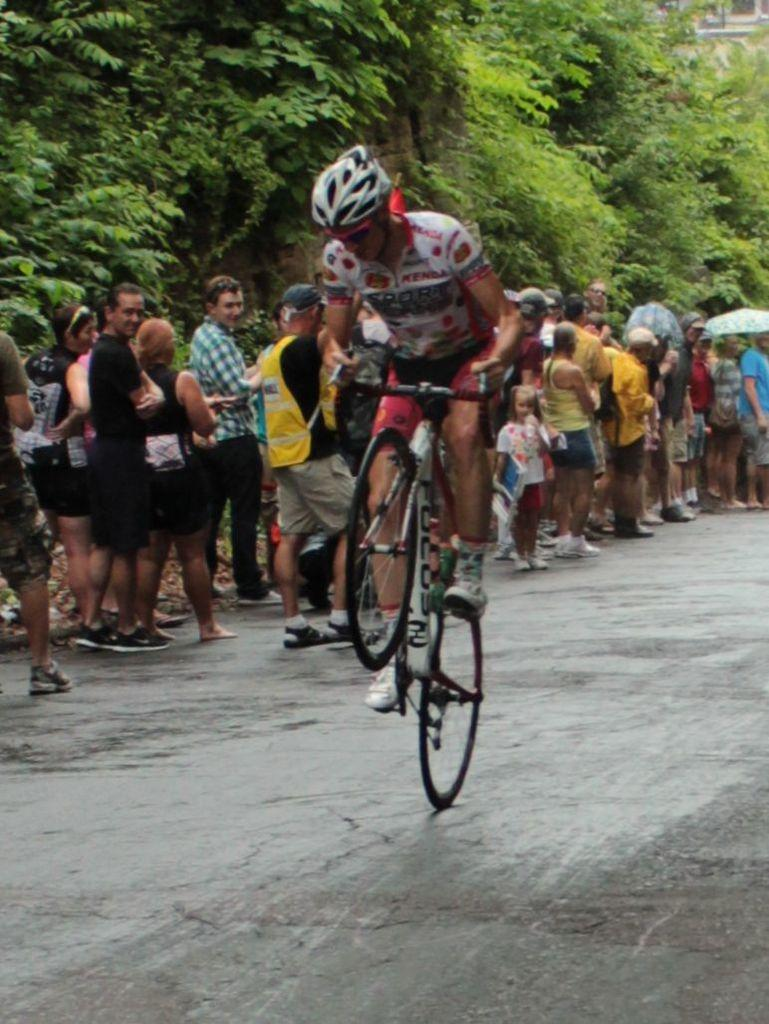What is the main subject of the image? There is a person riding a bicycle in the image. What are the people behind the cyclist doing? The people in the line are standing behind the cyclist. In which direction are the people in the line facing? The people in the line are facing the opposite direction of the cyclist. What can be seen beside the people in the line? There are trees beside the people in the line. Reasoning: Let'g: Let's think step by step in order to produce the conversation. We start by identifying the main subject of the image, which is the person riding a bicycle. Then, we describe the people standing in line behind the cyclist and their direction of facing. Finally, we mention the trees beside the people in the line, which are also visible in the image. Each question is designed to elicit a specific detail about the image that is known from the provided facts. Absurd Question/Answer: What language is the owl speaking to the cyclist in the image? There is no owl present in the image, so it cannot be speaking to the cyclist. 